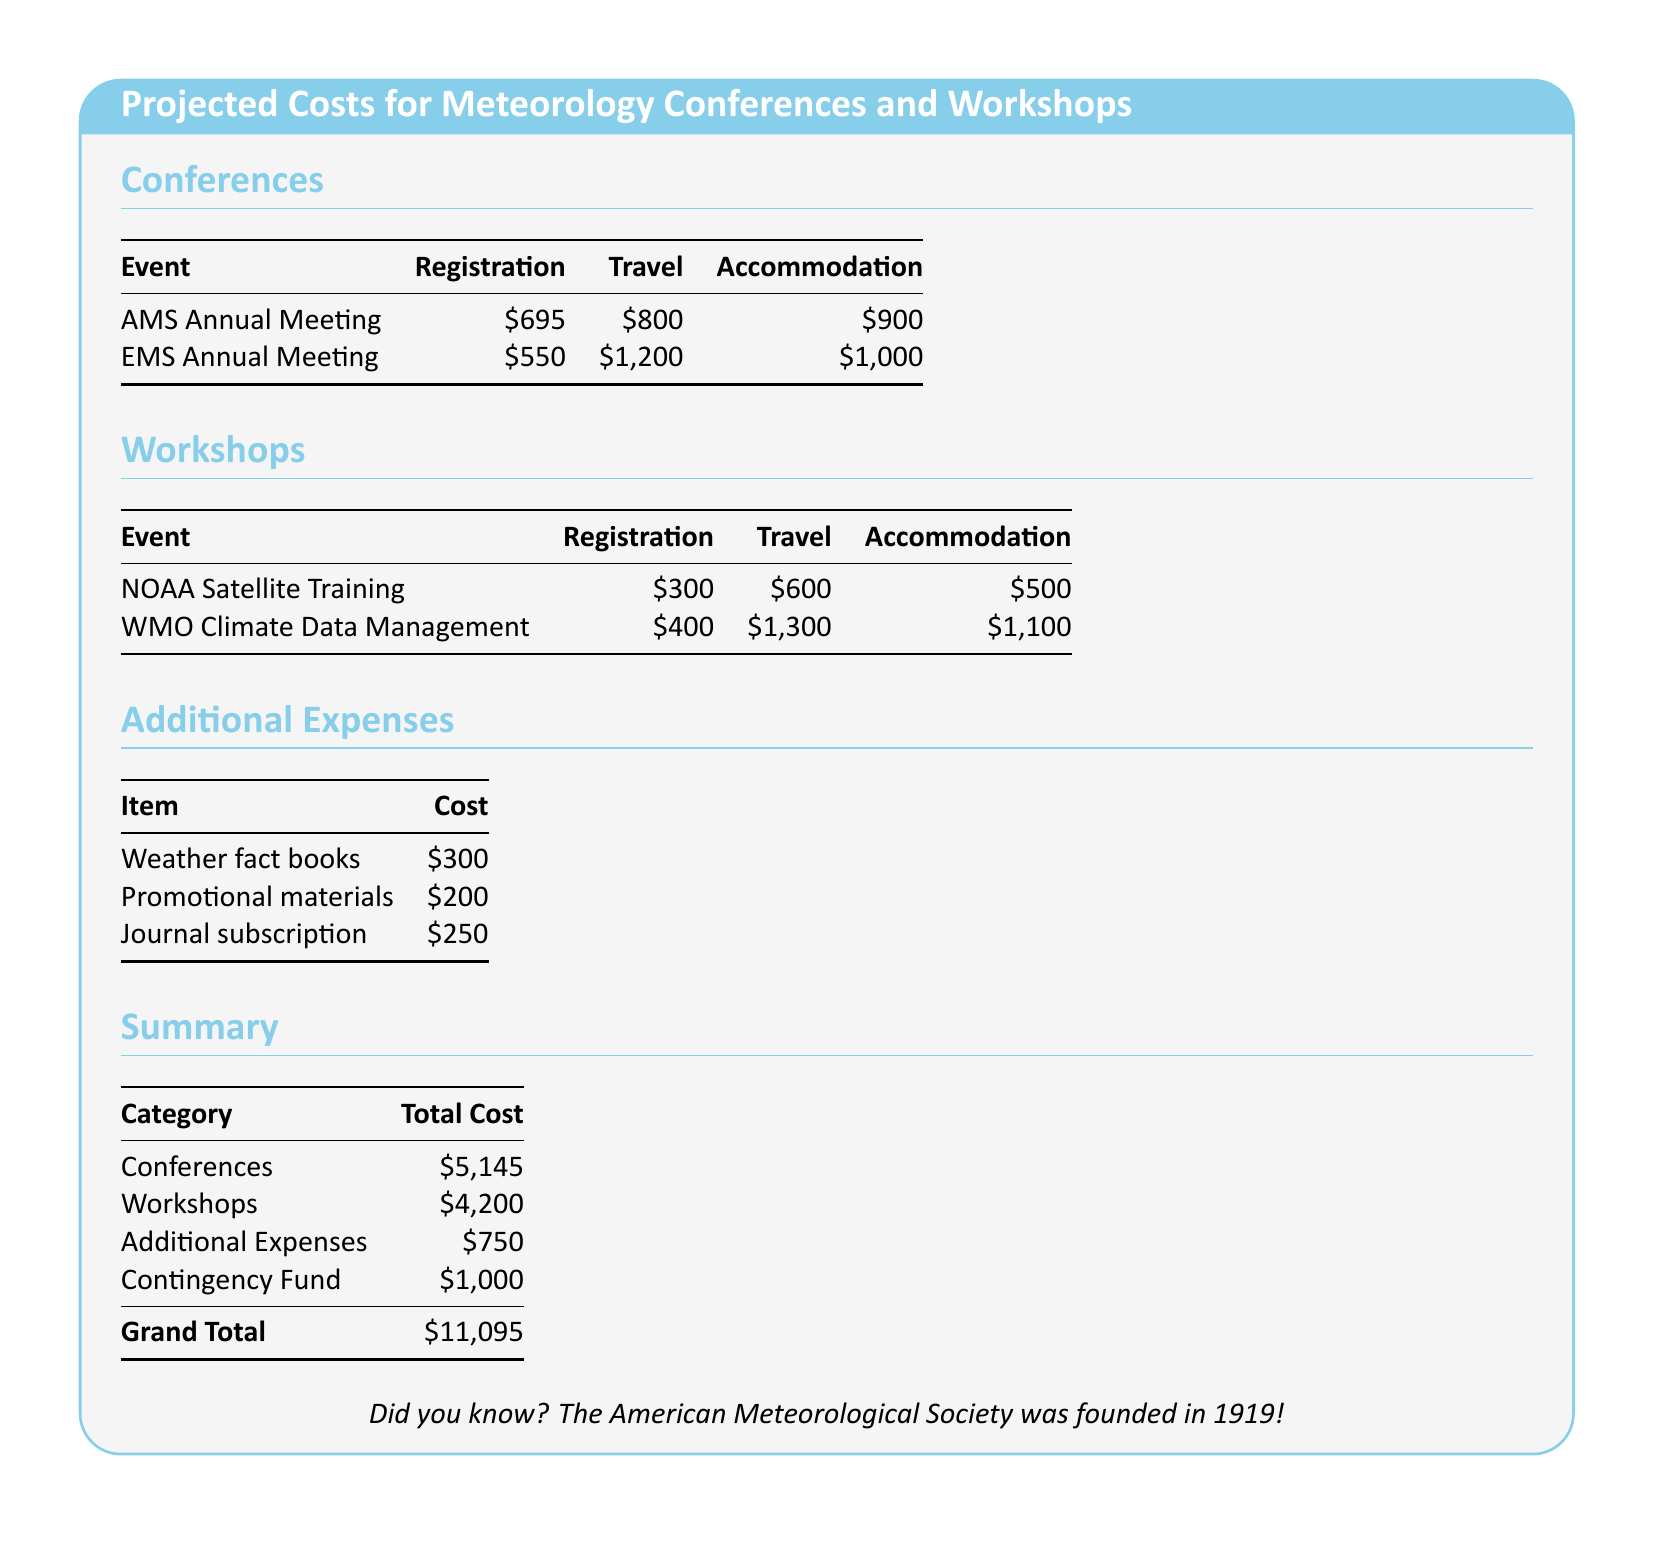What is the total cost for attending the AMS Annual Meeting? The total cost for the AMS Annual Meeting includes registration, travel, and accommodation: $695 + $800 + $900 = $2395.
Answer: $2395 What is the travel cost for the EMS Annual Meeting? The travel cost for the EMS Annual Meeting is specified in the document.
Answer: $1,200 Which workshop has the highest registration fee? The registration fees for the workshops are compared, revealing that the WMO Climate Data Management workshop has the highest fee at $400.
Answer: WMO Climate Data Management What is the total cost for additional expenses? The total cost for additional expenses is the sum of all listed items: $300 + $200 + $250 = $750.
Answer: $750 What is the grand total of all expenses listed in the document? The grand total is presented at the bottom of the summary table, which is the sum of conferences, workshops, additional expenses, and the contingency fund.
Answer: $11,095 How much does NOAA Satellite Training cost for travel? The travel cost specifically for the NOAA Satellite Training workshop is mentioned in the document.
Answer: $600 What is the accommodation cost for the WMO Climate Data Management workshop? The accommodation cost is detailed in the workshop section for the WMO Climate Data Management workshop.
Answer: $1,100 What is the total cost for attending all conferences? The total cost for conferences is provided in the summary section, aggregating all conference-related expenses.
Answer: $5,145 